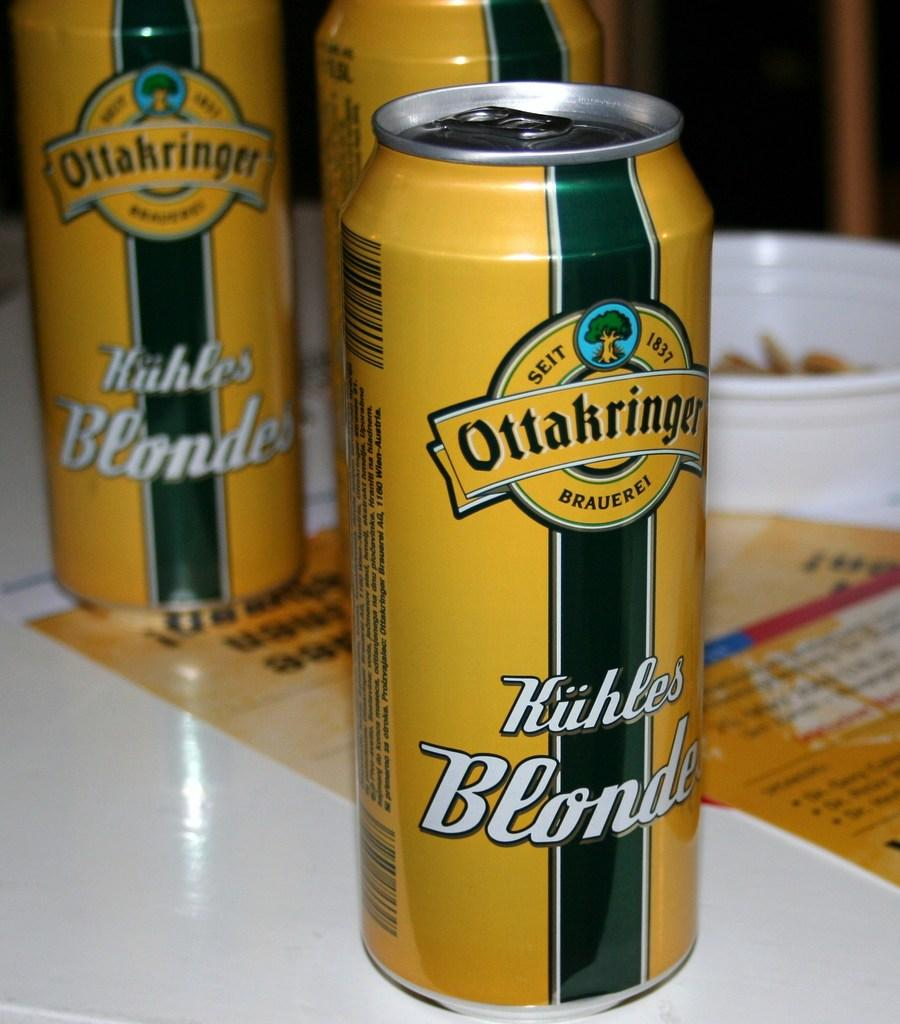Provide a one-sentence caption for the provided image. Three yellow cans of Ottakringer Kuhles Blonde, one in the foreground, two in the back. 